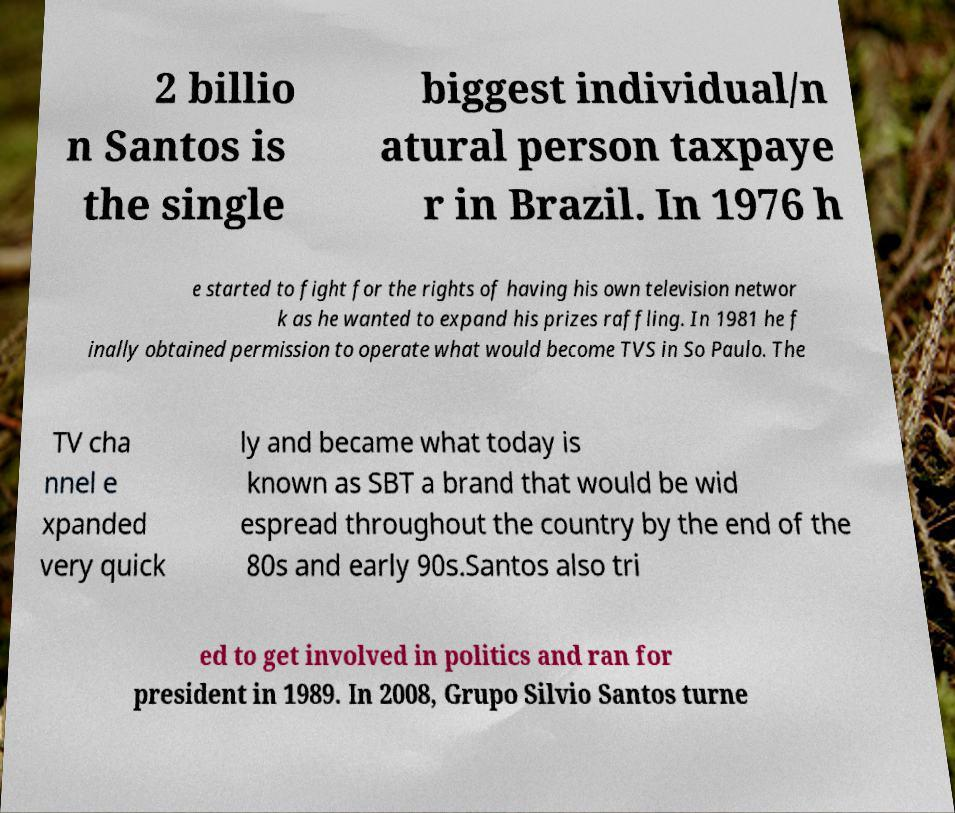For documentation purposes, I need the text within this image transcribed. Could you provide that? 2 billio n Santos is the single biggest individual/n atural person taxpaye r in Brazil. In 1976 h e started to fight for the rights of having his own television networ k as he wanted to expand his prizes raffling. In 1981 he f inally obtained permission to operate what would become TVS in So Paulo. The TV cha nnel e xpanded very quick ly and became what today is known as SBT a brand that would be wid espread throughout the country by the end of the 80s and early 90s.Santos also tri ed to get involved in politics and ran for president in 1989. In 2008, Grupo Silvio Santos turne 